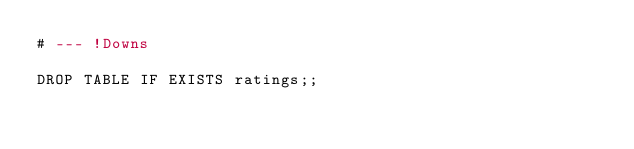<code> <loc_0><loc_0><loc_500><loc_500><_SQL_># --- !Downs

DROP TABLE IF EXISTS ratings;;
</code> 